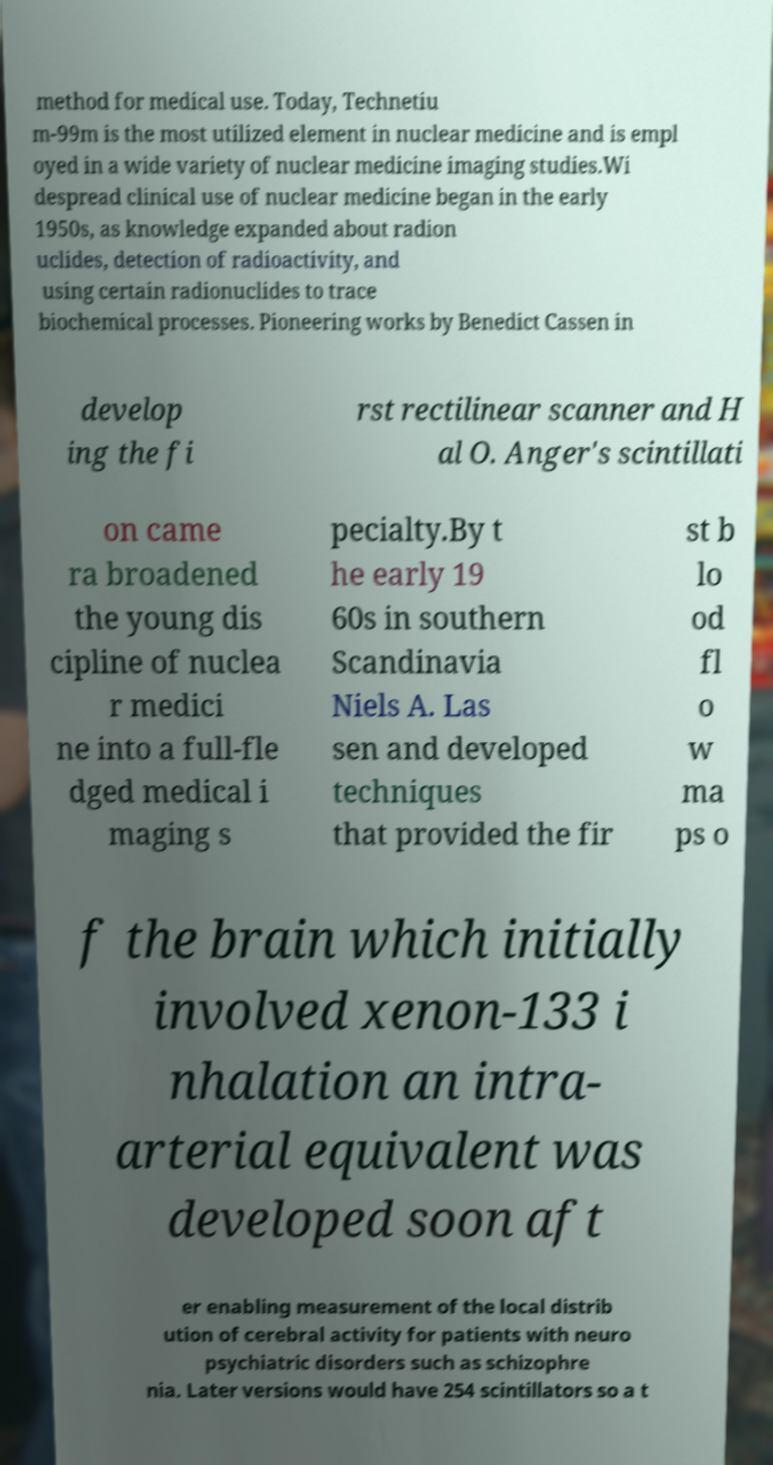I need the written content from this picture converted into text. Can you do that? method for medical use. Today, Technetiu m-99m is the most utilized element in nuclear medicine and is empl oyed in a wide variety of nuclear medicine imaging studies.Wi despread clinical use of nuclear medicine began in the early 1950s, as knowledge expanded about radion uclides, detection of radioactivity, and using certain radionuclides to trace biochemical processes. Pioneering works by Benedict Cassen in develop ing the fi rst rectilinear scanner and H al O. Anger's scintillati on came ra broadened the young dis cipline of nuclea r medici ne into a full-fle dged medical i maging s pecialty.By t he early 19 60s in southern Scandinavia Niels A. Las sen and developed techniques that provided the fir st b lo od fl o w ma ps o f the brain which initially involved xenon-133 i nhalation an intra- arterial equivalent was developed soon aft er enabling measurement of the local distrib ution of cerebral activity for patients with neuro psychiatric disorders such as schizophre nia. Later versions would have 254 scintillators so a t 